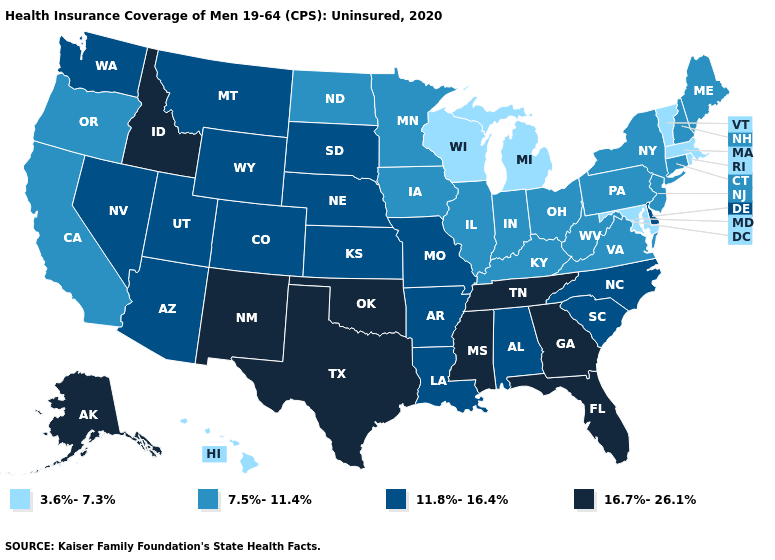What is the value of Wyoming?
Be succinct. 11.8%-16.4%. What is the value of Washington?
Short answer required. 11.8%-16.4%. Among the states that border Wyoming , does Utah have the highest value?
Be succinct. No. What is the value of Pennsylvania?
Keep it brief. 7.5%-11.4%. What is the highest value in the MidWest ?
Be succinct. 11.8%-16.4%. Is the legend a continuous bar?
Write a very short answer. No. Which states hav the highest value in the Northeast?
Write a very short answer. Connecticut, Maine, New Hampshire, New Jersey, New York, Pennsylvania. Name the states that have a value in the range 11.8%-16.4%?
Give a very brief answer. Alabama, Arizona, Arkansas, Colorado, Delaware, Kansas, Louisiana, Missouri, Montana, Nebraska, Nevada, North Carolina, South Carolina, South Dakota, Utah, Washington, Wyoming. Among the states that border Iowa , which have the highest value?
Concise answer only. Missouri, Nebraska, South Dakota. Name the states that have a value in the range 16.7%-26.1%?
Answer briefly. Alaska, Florida, Georgia, Idaho, Mississippi, New Mexico, Oklahoma, Tennessee, Texas. Name the states that have a value in the range 3.6%-7.3%?
Short answer required. Hawaii, Maryland, Massachusetts, Michigan, Rhode Island, Vermont, Wisconsin. Name the states that have a value in the range 11.8%-16.4%?
Write a very short answer. Alabama, Arizona, Arkansas, Colorado, Delaware, Kansas, Louisiana, Missouri, Montana, Nebraska, Nevada, North Carolina, South Carolina, South Dakota, Utah, Washington, Wyoming. Which states have the lowest value in the USA?
Short answer required. Hawaii, Maryland, Massachusetts, Michigan, Rhode Island, Vermont, Wisconsin. Among the states that border Tennessee , which have the highest value?
Concise answer only. Georgia, Mississippi. What is the lowest value in the USA?
Be succinct. 3.6%-7.3%. 